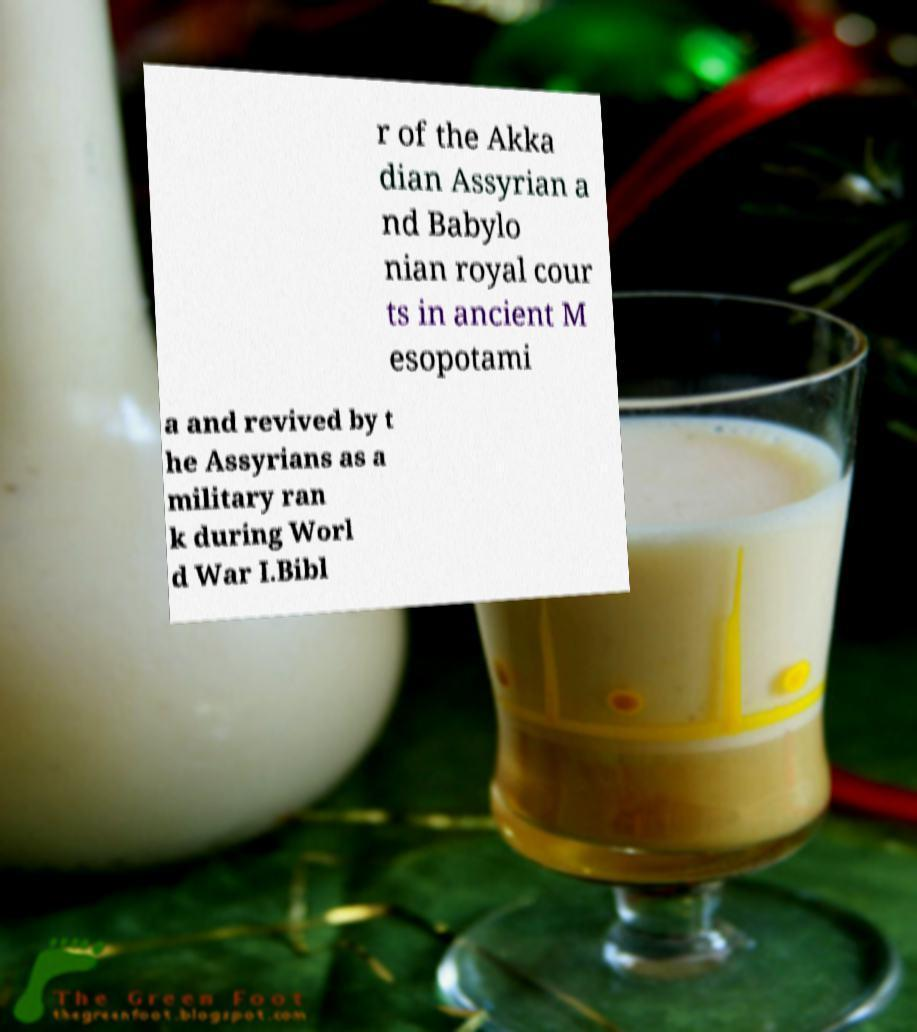Could you extract and type out the text from this image? r of the Akka dian Assyrian a nd Babylo nian royal cour ts in ancient M esopotami a and revived by t he Assyrians as a military ran k during Worl d War I.Bibl 